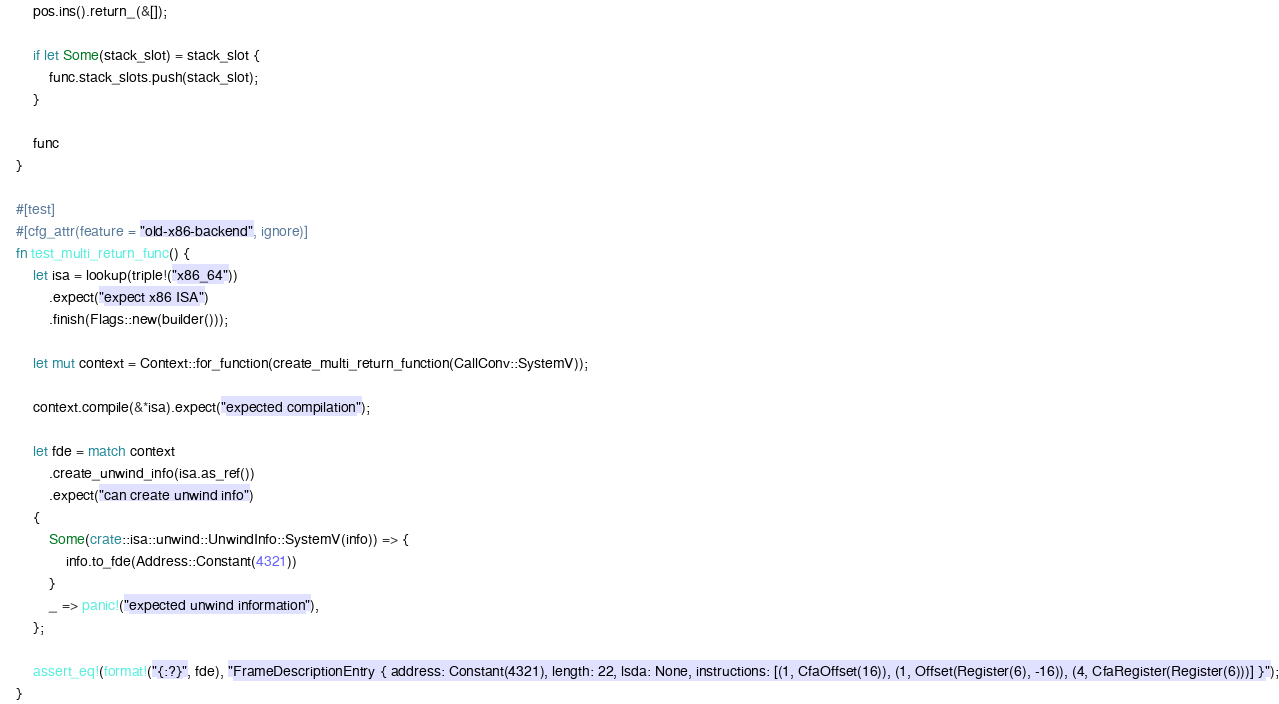<code> <loc_0><loc_0><loc_500><loc_500><_Rust_>        pos.ins().return_(&[]);

        if let Some(stack_slot) = stack_slot {
            func.stack_slots.push(stack_slot);
        }

        func
    }

    #[test]
    #[cfg_attr(feature = "old-x86-backend", ignore)]
    fn test_multi_return_func() {
        let isa = lookup(triple!("x86_64"))
            .expect("expect x86 ISA")
            .finish(Flags::new(builder()));

        let mut context = Context::for_function(create_multi_return_function(CallConv::SystemV));

        context.compile(&*isa).expect("expected compilation");

        let fde = match context
            .create_unwind_info(isa.as_ref())
            .expect("can create unwind info")
        {
            Some(crate::isa::unwind::UnwindInfo::SystemV(info)) => {
                info.to_fde(Address::Constant(4321))
            }
            _ => panic!("expected unwind information"),
        };

        assert_eq!(format!("{:?}", fde), "FrameDescriptionEntry { address: Constant(4321), length: 22, lsda: None, instructions: [(1, CfaOffset(16)), (1, Offset(Register(6), -16)), (4, CfaRegister(Register(6)))] }");
    }
</code> 